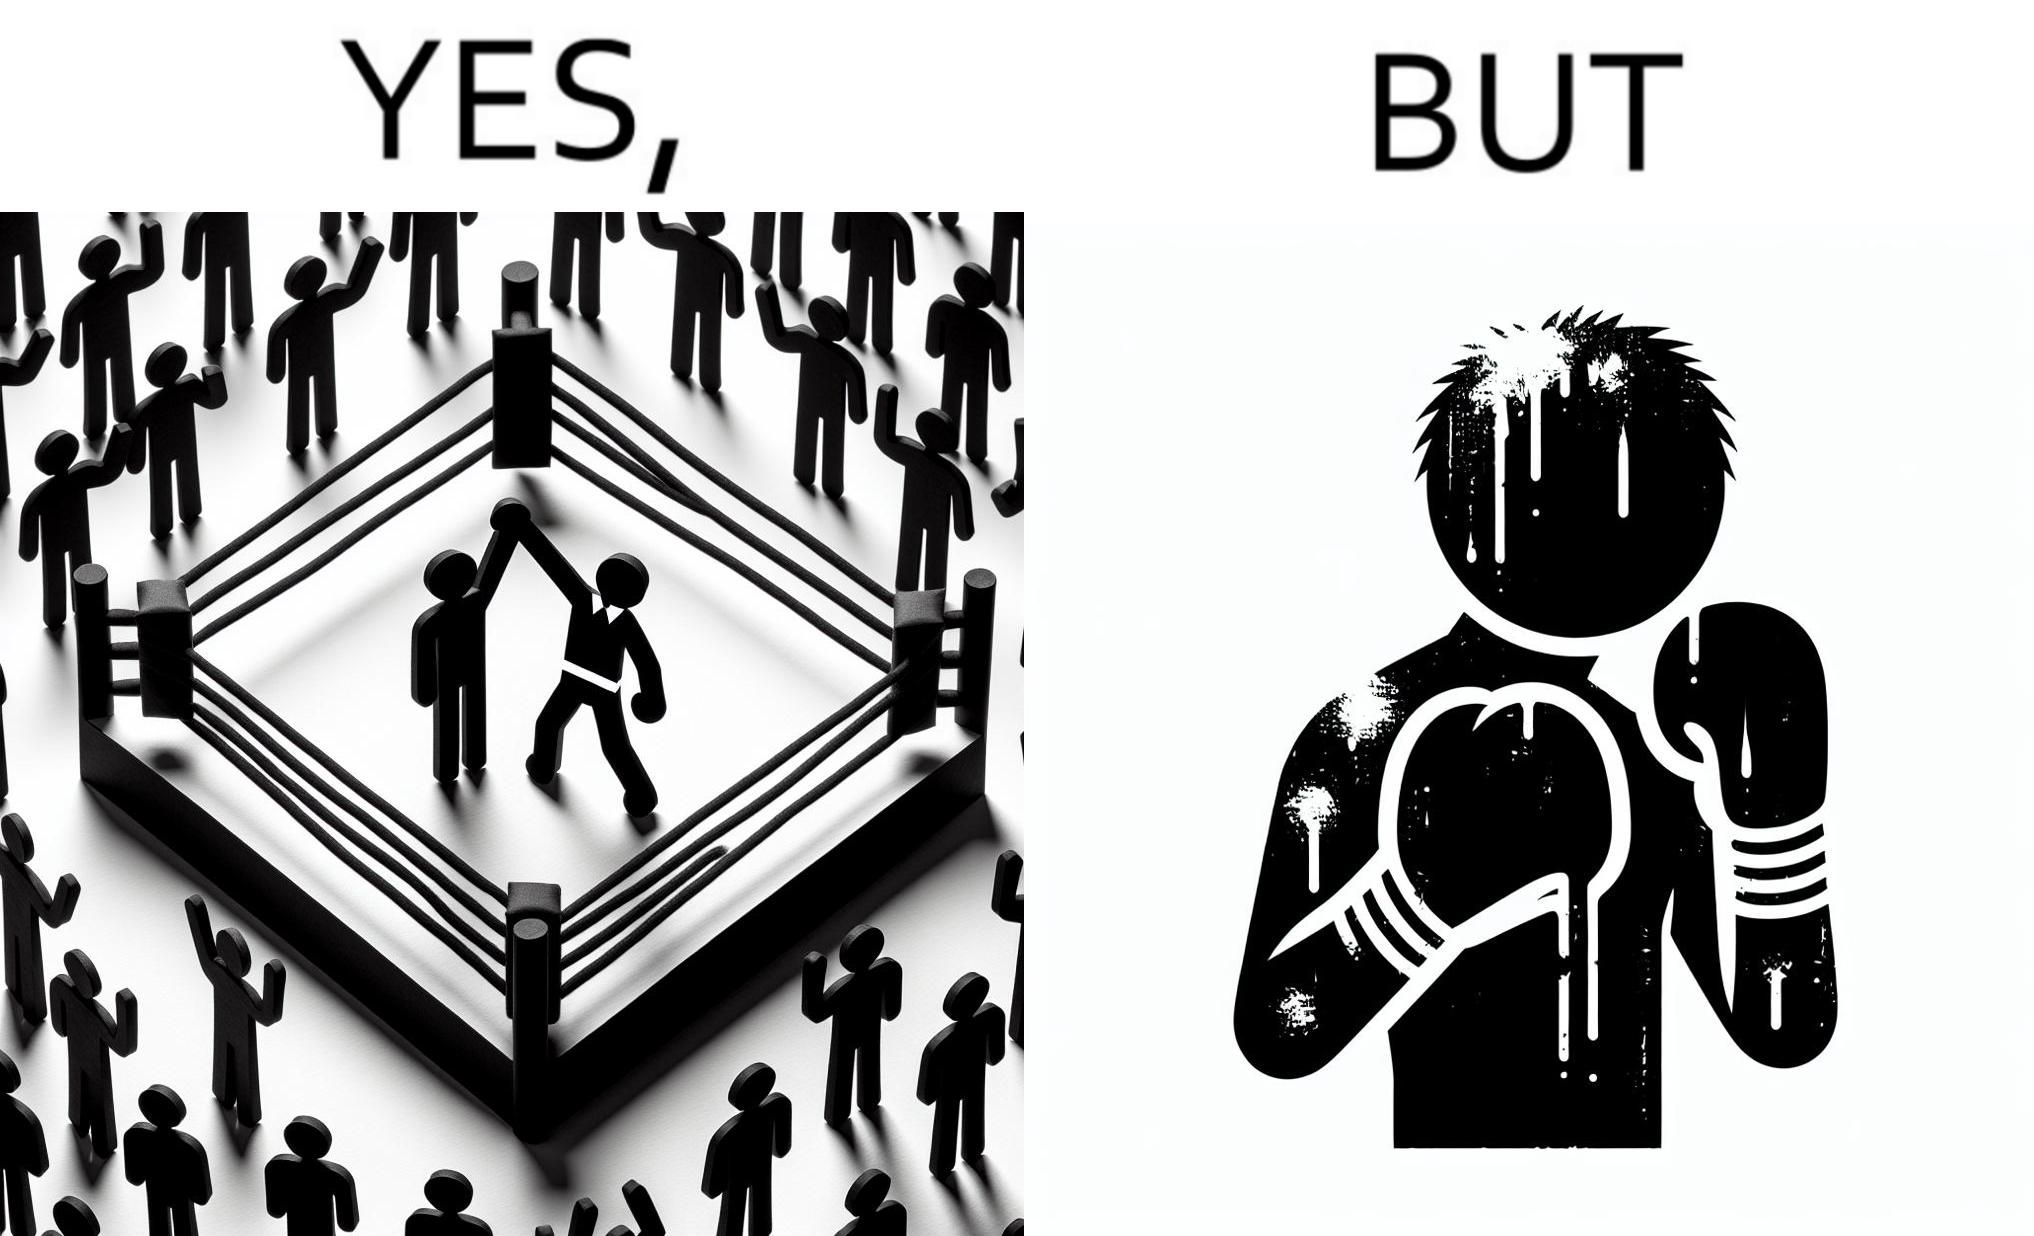Is this a satirical image? Yes, this image is satirical. 